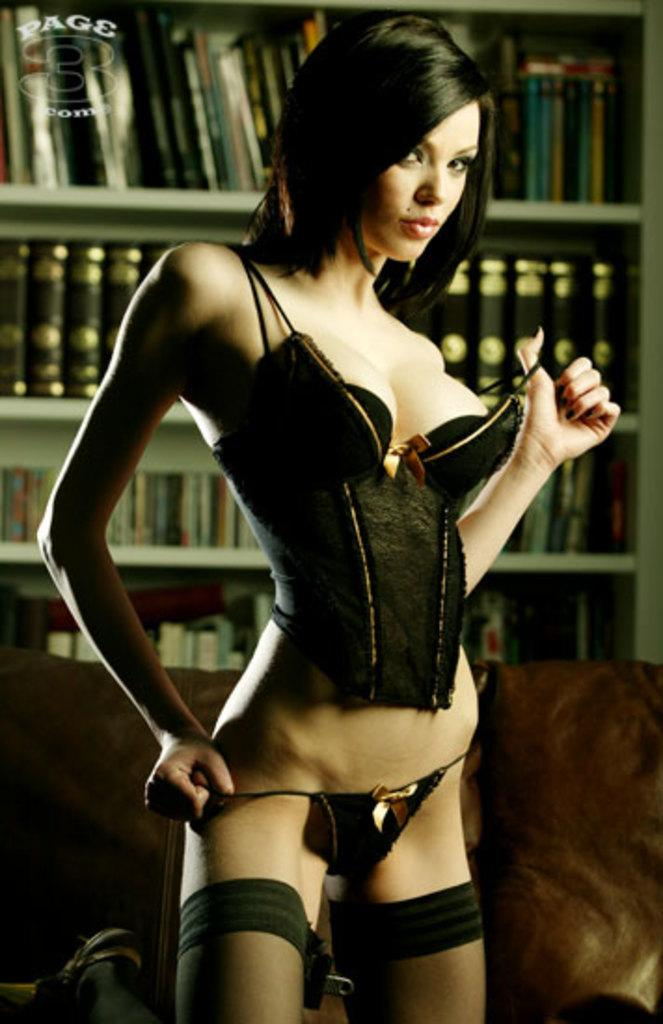Who is present in the image? There is a woman in the image. What is the woman wearing? The woman is wearing a black dress. What is the woman doing in the image? The woman is standing. What can be seen in the background of the image? There are books in a rack in the background of the image. How many nuts are visible on the woman's legs in the image? There are no nuts visible on the woman's legs in the image. 